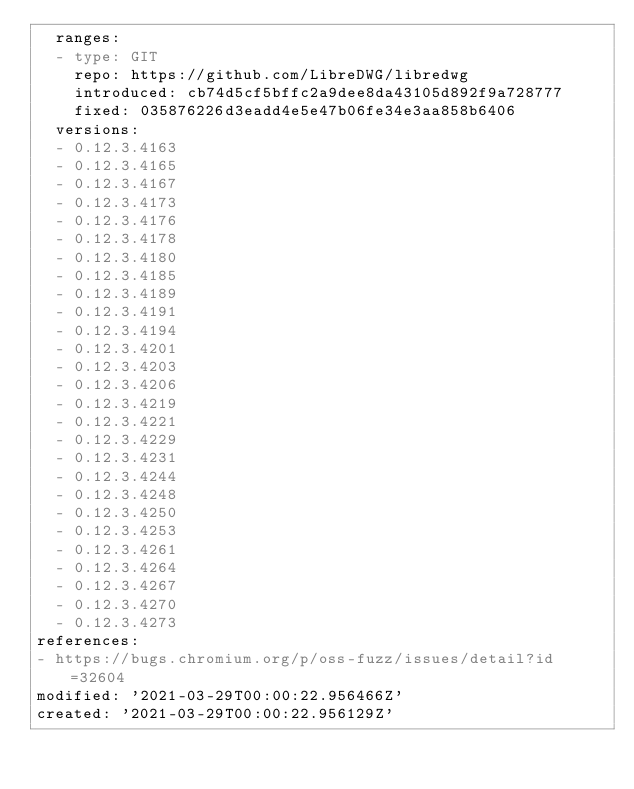Convert code to text. <code><loc_0><loc_0><loc_500><loc_500><_YAML_>  ranges:
  - type: GIT
    repo: https://github.com/LibreDWG/libredwg
    introduced: cb74d5cf5bffc2a9dee8da43105d892f9a728777
    fixed: 035876226d3eadd4e5e47b06fe34e3aa858b6406
  versions:
  - 0.12.3.4163
  - 0.12.3.4165
  - 0.12.3.4167
  - 0.12.3.4173
  - 0.12.3.4176
  - 0.12.3.4178
  - 0.12.3.4180
  - 0.12.3.4185
  - 0.12.3.4189
  - 0.12.3.4191
  - 0.12.3.4194
  - 0.12.3.4201
  - 0.12.3.4203
  - 0.12.3.4206
  - 0.12.3.4219
  - 0.12.3.4221
  - 0.12.3.4229
  - 0.12.3.4231
  - 0.12.3.4244
  - 0.12.3.4248
  - 0.12.3.4250
  - 0.12.3.4253
  - 0.12.3.4261
  - 0.12.3.4264
  - 0.12.3.4267
  - 0.12.3.4270
  - 0.12.3.4273
references:
- https://bugs.chromium.org/p/oss-fuzz/issues/detail?id=32604
modified: '2021-03-29T00:00:22.956466Z'
created: '2021-03-29T00:00:22.956129Z'
</code> 